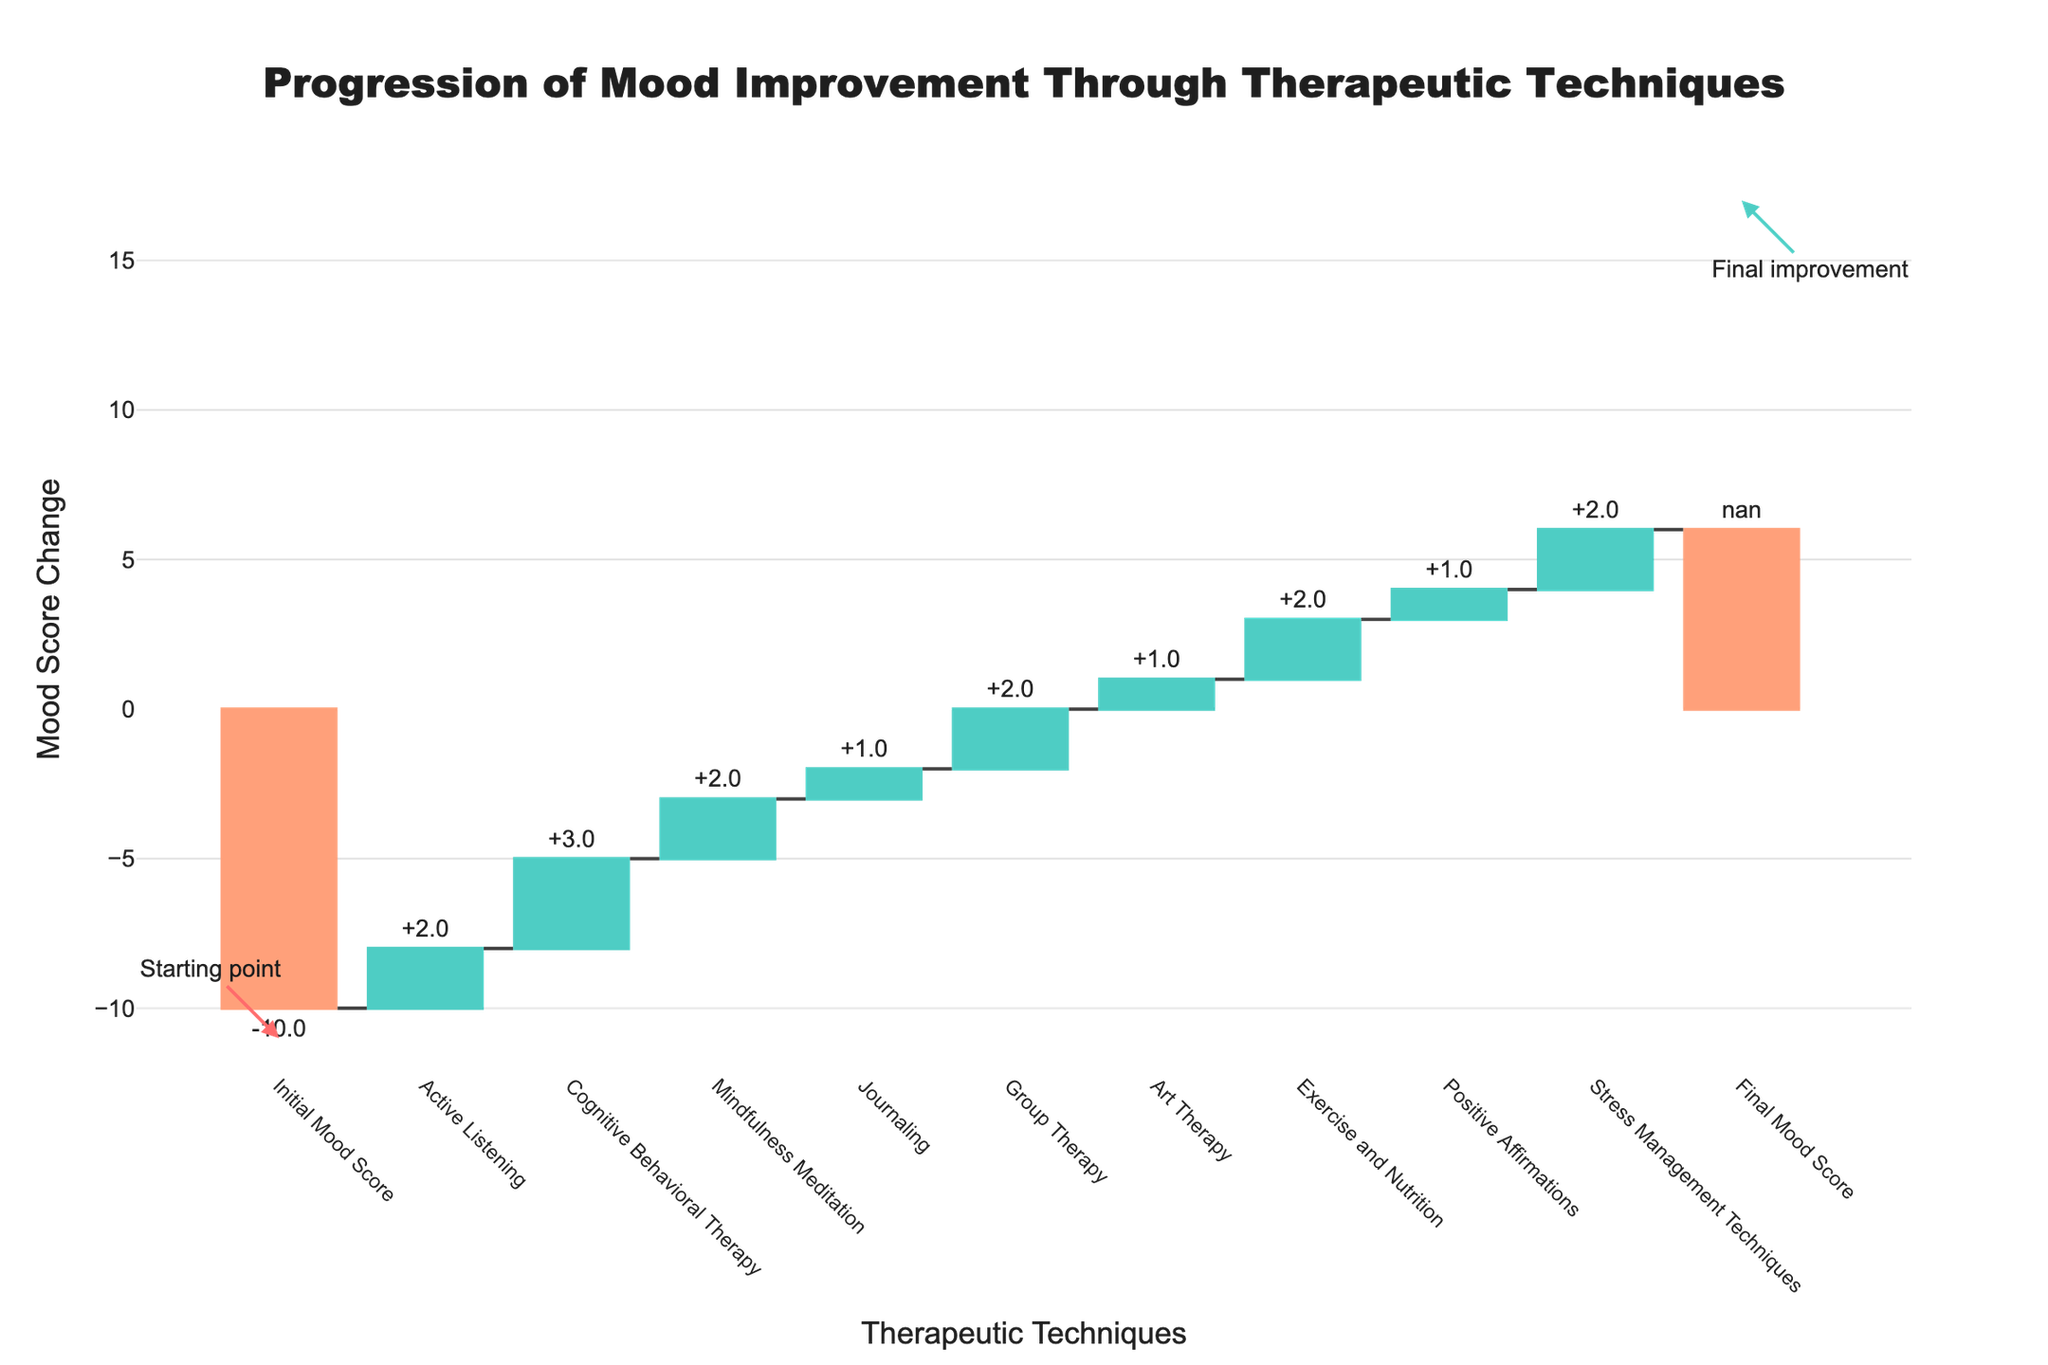What is the title of the chart? The title of the chart is prominently displayed at the top and summarizes the chart's purpose.
Answer: "Progression of Mood Improvement Through Therapeutic Techniques" How many therapeutic techniques are listed in the chart? Count each step labeled after the initial mood score.
Answer: 10 Which therapeutic technique contributed the most to mood improvement? Look for the highest positive bar among the techniques.
Answer: Cognitive Behavioral Therapy What is the final mood score after all therapeutic techniques? Check the final value shown on the chart.
Answer: 16 By how much did the 'Active Listening' technique improve the mood? Check the labeled value of the 'Active Listening' bar.
Answer: 2 Which techniques contributed equally to mood improvement? Identify bars with the same length and same positive or negative value.
Answer: Active Listening, Mindfulness Meditation, Group Therapy, Stress Management Techniques What is the total mood improvement contributed by all techniques combined? Sum all the positive values of mood improvements from the techniques.
Answer: 16 How much did the 'Exercise and Nutrition' technique improve the mood compared to 'Positive Affirmations'? Subtract the 'Positive Affirmations' value from the 'Exercise and Nutrition' value.
Answer: 1 How does the mood change visually differ between positive and negative values in chart colors? Describe the color coding for positive and negative mood changes.
Answer: Positive values are green, negative values are red What annotation is marked at the starting point on the chart? Check the text and the arrow that points to the initial bar of the chart.
Answer: Starting point What annotation is marked at the endpoint on the chart? Check the text and the arrow that points to the final bar of the chart.
Answer: Final improvement 